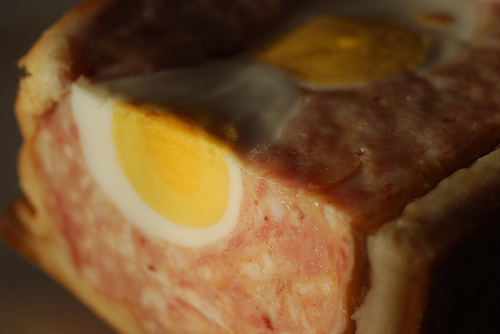<image>
Is there a yoke on the meat? No. The yoke is not positioned on the meat. They may be near each other, but the yoke is not supported by or resting on top of the meat. 